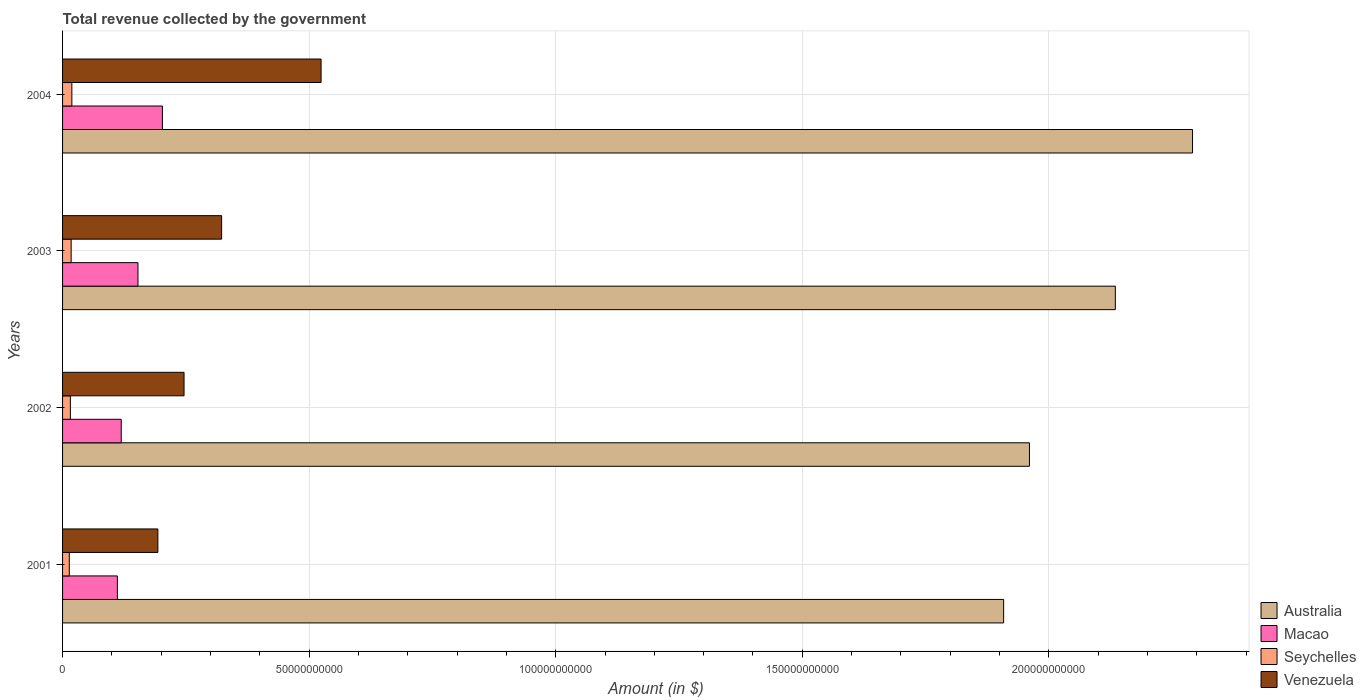Are the number of bars per tick equal to the number of legend labels?
Offer a very short reply. Yes. What is the label of the 4th group of bars from the top?
Ensure brevity in your answer.  2001. In how many cases, is the number of bars for a given year not equal to the number of legend labels?
Give a very brief answer. 0. What is the total revenue collected by the government in Macao in 2003?
Ensure brevity in your answer.  1.53e+1. Across all years, what is the maximum total revenue collected by the government in Macao?
Give a very brief answer. 2.02e+1. Across all years, what is the minimum total revenue collected by the government in Macao?
Provide a succinct answer. 1.11e+1. In which year was the total revenue collected by the government in Venezuela maximum?
Your answer should be compact. 2004. What is the total total revenue collected by the government in Venezuela in the graph?
Offer a very short reply. 1.29e+11. What is the difference between the total revenue collected by the government in Macao in 2001 and that in 2004?
Make the answer very short. -9.14e+09. What is the difference between the total revenue collected by the government in Seychelles in 2004 and the total revenue collected by the government in Venezuela in 2003?
Provide a succinct answer. -3.04e+1. What is the average total revenue collected by the government in Seychelles per year?
Your answer should be compact. 1.64e+09. In the year 2004, what is the difference between the total revenue collected by the government in Australia and total revenue collected by the government in Venezuela?
Provide a short and direct response. 1.77e+11. In how many years, is the total revenue collected by the government in Seychelles greater than 160000000000 $?
Your answer should be very brief. 0. What is the ratio of the total revenue collected by the government in Venezuela in 2001 to that in 2002?
Make the answer very short. 0.78. What is the difference between the highest and the second highest total revenue collected by the government in Macao?
Offer a very short reply. 4.96e+09. What is the difference between the highest and the lowest total revenue collected by the government in Seychelles?
Your response must be concise. 5.19e+08. In how many years, is the total revenue collected by the government in Venezuela greater than the average total revenue collected by the government in Venezuela taken over all years?
Your answer should be compact. 2. Is the sum of the total revenue collected by the government in Macao in 2001 and 2002 greater than the maximum total revenue collected by the government in Australia across all years?
Your answer should be compact. No. What does the 2nd bar from the bottom in 2002 represents?
Your response must be concise. Macao. Is it the case that in every year, the sum of the total revenue collected by the government in Venezuela and total revenue collected by the government in Macao is greater than the total revenue collected by the government in Australia?
Your response must be concise. No. How many years are there in the graph?
Provide a short and direct response. 4. Are the values on the major ticks of X-axis written in scientific E-notation?
Provide a short and direct response. No. Does the graph contain grids?
Your answer should be very brief. Yes. Where does the legend appear in the graph?
Offer a terse response. Bottom right. How many legend labels are there?
Make the answer very short. 4. What is the title of the graph?
Provide a succinct answer. Total revenue collected by the government. Does "Nicaragua" appear as one of the legend labels in the graph?
Your answer should be compact. No. What is the label or title of the X-axis?
Provide a succinct answer. Amount (in $). What is the Amount (in $) in Australia in 2001?
Give a very brief answer. 1.91e+11. What is the Amount (in $) in Macao in 2001?
Make the answer very short. 1.11e+1. What is the Amount (in $) of Seychelles in 2001?
Your response must be concise. 1.36e+09. What is the Amount (in $) of Venezuela in 2001?
Give a very brief answer. 1.93e+1. What is the Amount (in $) of Australia in 2002?
Provide a short and direct response. 1.96e+11. What is the Amount (in $) of Macao in 2002?
Make the answer very short. 1.19e+1. What is the Amount (in $) in Seychelles in 2002?
Your response must be concise. 1.58e+09. What is the Amount (in $) of Venezuela in 2002?
Offer a very short reply. 2.46e+1. What is the Amount (in $) in Australia in 2003?
Offer a terse response. 2.13e+11. What is the Amount (in $) in Macao in 2003?
Give a very brief answer. 1.53e+1. What is the Amount (in $) in Seychelles in 2003?
Offer a terse response. 1.74e+09. What is the Amount (in $) in Venezuela in 2003?
Provide a short and direct response. 3.23e+1. What is the Amount (in $) of Australia in 2004?
Your answer should be compact. 2.29e+11. What is the Amount (in $) in Macao in 2004?
Your answer should be compact. 2.02e+1. What is the Amount (in $) of Seychelles in 2004?
Your response must be concise. 1.88e+09. What is the Amount (in $) of Venezuela in 2004?
Provide a succinct answer. 5.24e+1. Across all years, what is the maximum Amount (in $) in Australia?
Offer a very short reply. 2.29e+11. Across all years, what is the maximum Amount (in $) of Macao?
Your response must be concise. 2.02e+1. Across all years, what is the maximum Amount (in $) in Seychelles?
Offer a terse response. 1.88e+09. Across all years, what is the maximum Amount (in $) in Venezuela?
Give a very brief answer. 5.24e+1. Across all years, what is the minimum Amount (in $) of Australia?
Your answer should be compact. 1.91e+11. Across all years, what is the minimum Amount (in $) of Macao?
Offer a very short reply. 1.11e+1. Across all years, what is the minimum Amount (in $) of Seychelles?
Provide a succinct answer. 1.36e+09. Across all years, what is the minimum Amount (in $) in Venezuela?
Your answer should be compact. 1.93e+1. What is the total Amount (in $) in Australia in the graph?
Ensure brevity in your answer.  8.29e+11. What is the total Amount (in $) of Macao in the graph?
Make the answer very short. 5.85e+1. What is the total Amount (in $) in Seychelles in the graph?
Your answer should be compact. 6.57e+09. What is the total Amount (in $) in Venezuela in the graph?
Ensure brevity in your answer.  1.29e+11. What is the difference between the Amount (in $) of Australia in 2001 and that in 2002?
Make the answer very short. -5.24e+09. What is the difference between the Amount (in $) of Macao in 2001 and that in 2002?
Provide a short and direct response. -7.85e+08. What is the difference between the Amount (in $) in Seychelles in 2001 and that in 2002?
Offer a very short reply. -2.17e+08. What is the difference between the Amount (in $) in Venezuela in 2001 and that in 2002?
Give a very brief answer. -5.31e+09. What is the difference between the Amount (in $) of Australia in 2001 and that in 2003?
Make the answer very short. -2.27e+1. What is the difference between the Amount (in $) of Macao in 2001 and that in 2003?
Provide a short and direct response. -4.18e+09. What is the difference between the Amount (in $) of Seychelles in 2001 and that in 2003?
Your answer should be very brief. -3.78e+08. What is the difference between the Amount (in $) in Venezuela in 2001 and that in 2003?
Give a very brief answer. -1.29e+1. What is the difference between the Amount (in $) of Australia in 2001 and that in 2004?
Provide a succinct answer. -3.83e+1. What is the difference between the Amount (in $) in Macao in 2001 and that in 2004?
Offer a terse response. -9.14e+09. What is the difference between the Amount (in $) of Seychelles in 2001 and that in 2004?
Your response must be concise. -5.19e+08. What is the difference between the Amount (in $) in Venezuela in 2001 and that in 2004?
Provide a short and direct response. -3.31e+1. What is the difference between the Amount (in $) of Australia in 2002 and that in 2003?
Keep it short and to the point. -1.74e+1. What is the difference between the Amount (in $) in Macao in 2002 and that in 2003?
Offer a terse response. -3.39e+09. What is the difference between the Amount (in $) of Seychelles in 2002 and that in 2003?
Offer a terse response. -1.61e+08. What is the difference between the Amount (in $) of Venezuela in 2002 and that in 2003?
Your response must be concise. -7.62e+09. What is the difference between the Amount (in $) of Australia in 2002 and that in 2004?
Keep it short and to the point. -3.31e+1. What is the difference between the Amount (in $) of Macao in 2002 and that in 2004?
Your answer should be very brief. -8.35e+09. What is the difference between the Amount (in $) of Seychelles in 2002 and that in 2004?
Offer a terse response. -3.02e+08. What is the difference between the Amount (in $) in Venezuela in 2002 and that in 2004?
Offer a very short reply. -2.78e+1. What is the difference between the Amount (in $) in Australia in 2003 and that in 2004?
Provide a short and direct response. -1.56e+1. What is the difference between the Amount (in $) in Macao in 2003 and that in 2004?
Keep it short and to the point. -4.96e+09. What is the difference between the Amount (in $) of Seychelles in 2003 and that in 2004?
Provide a succinct answer. -1.41e+08. What is the difference between the Amount (in $) in Venezuela in 2003 and that in 2004?
Your response must be concise. -2.02e+1. What is the difference between the Amount (in $) of Australia in 2001 and the Amount (in $) of Macao in 2002?
Give a very brief answer. 1.79e+11. What is the difference between the Amount (in $) of Australia in 2001 and the Amount (in $) of Seychelles in 2002?
Offer a terse response. 1.89e+11. What is the difference between the Amount (in $) in Australia in 2001 and the Amount (in $) in Venezuela in 2002?
Ensure brevity in your answer.  1.66e+11. What is the difference between the Amount (in $) of Macao in 2001 and the Amount (in $) of Seychelles in 2002?
Provide a short and direct response. 9.53e+09. What is the difference between the Amount (in $) of Macao in 2001 and the Amount (in $) of Venezuela in 2002?
Ensure brevity in your answer.  -1.35e+1. What is the difference between the Amount (in $) of Seychelles in 2001 and the Amount (in $) of Venezuela in 2002?
Provide a succinct answer. -2.33e+1. What is the difference between the Amount (in $) in Australia in 2001 and the Amount (in $) in Macao in 2003?
Offer a very short reply. 1.76e+11. What is the difference between the Amount (in $) of Australia in 2001 and the Amount (in $) of Seychelles in 2003?
Your answer should be compact. 1.89e+11. What is the difference between the Amount (in $) of Australia in 2001 and the Amount (in $) of Venezuela in 2003?
Give a very brief answer. 1.59e+11. What is the difference between the Amount (in $) in Macao in 2001 and the Amount (in $) in Seychelles in 2003?
Make the answer very short. 9.37e+09. What is the difference between the Amount (in $) in Macao in 2001 and the Amount (in $) in Venezuela in 2003?
Make the answer very short. -2.11e+1. What is the difference between the Amount (in $) in Seychelles in 2001 and the Amount (in $) in Venezuela in 2003?
Make the answer very short. -3.09e+1. What is the difference between the Amount (in $) in Australia in 2001 and the Amount (in $) in Macao in 2004?
Ensure brevity in your answer.  1.71e+11. What is the difference between the Amount (in $) in Australia in 2001 and the Amount (in $) in Seychelles in 2004?
Your answer should be very brief. 1.89e+11. What is the difference between the Amount (in $) of Australia in 2001 and the Amount (in $) of Venezuela in 2004?
Your answer should be compact. 1.38e+11. What is the difference between the Amount (in $) in Macao in 2001 and the Amount (in $) in Seychelles in 2004?
Keep it short and to the point. 9.23e+09. What is the difference between the Amount (in $) of Macao in 2001 and the Amount (in $) of Venezuela in 2004?
Provide a short and direct response. -4.13e+1. What is the difference between the Amount (in $) in Seychelles in 2001 and the Amount (in $) in Venezuela in 2004?
Your response must be concise. -5.11e+1. What is the difference between the Amount (in $) of Australia in 2002 and the Amount (in $) of Macao in 2003?
Offer a terse response. 1.81e+11. What is the difference between the Amount (in $) of Australia in 2002 and the Amount (in $) of Seychelles in 2003?
Provide a succinct answer. 1.94e+11. What is the difference between the Amount (in $) in Australia in 2002 and the Amount (in $) in Venezuela in 2003?
Provide a short and direct response. 1.64e+11. What is the difference between the Amount (in $) of Macao in 2002 and the Amount (in $) of Seychelles in 2003?
Make the answer very short. 1.02e+1. What is the difference between the Amount (in $) of Macao in 2002 and the Amount (in $) of Venezuela in 2003?
Your answer should be very brief. -2.04e+1. What is the difference between the Amount (in $) of Seychelles in 2002 and the Amount (in $) of Venezuela in 2003?
Offer a very short reply. -3.07e+1. What is the difference between the Amount (in $) in Australia in 2002 and the Amount (in $) in Macao in 2004?
Keep it short and to the point. 1.76e+11. What is the difference between the Amount (in $) in Australia in 2002 and the Amount (in $) in Seychelles in 2004?
Give a very brief answer. 1.94e+11. What is the difference between the Amount (in $) in Australia in 2002 and the Amount (in $) in Venezuela in 2004?
Keep it short and to the point. 1.44e+11. What is the difference between the Amount (in $) of Macao in 2002 and the Amount (in $) of Seychelles in 2004?
Provide a short and direct response. 1.00e+1. What is the difference between the Amount (in $) in Macao in 2002 and the Amount (in $) in Venezuela in 2004?
Give a very brief answer. -4.05e+1. What is the difference between the Amount (in $) of Seychelles in 2002 and the Amount (in $) of Venezuela in 2004?
Provide a succinct answer. -5.08e+1. What is the difference between the Amount (in $) in Australia in 2003 and the Amount (in $) in Macao in 2004?
Your answer should be very brief. 1.93e+11. What is the difference between the Amount (in $) of Australia in 2003 and the Amount (in $) of Seychelles in 2004?
Provide a short and direct response. 2.12e+11. What is the difference between the Amount (in $) in Australia in 2003 and the Amount (in $) in Venezuela in 2004?
Offer a terse response. 1.61e+11. What is the difference between the Amount (in $) in Macao in 2003 and the Amount (in $) in Seychelles in 2004?
Your answer should be compact. 1.34e+1. What is the difference between the Amount (in $) in Macao in 2003 and the Amount (in $) in Venezuela in 2004?
Offer a terse response. -3.71e+1. What is the difference between the Amount (in $) of Seychelles in 2003 and the Amount (in $) of Venezuela in 2004?
Your response must be concise. -5.07e+1. What is the average Amount (in $) in Australia per year?
Offer a very short reply. 2.07e+11. What is the average Amount (in $) of Macao per year?
Give a very brief answer. 1.46e+1. What is the average Amount (in $) of Seychelles per year?
Keep it short and to the point. 1.64e+09. What is the average Amount (in $) of Venezuela per year?
Offer a terse response. 3.22e+1. In the year 2001, what is the difference between the Amount (in $) of Australia and Amount (in $) of Macao?
Provide a succinct answer. 1.80e+11. In the year 2001, what is the difference between the Amount (in $) of Australia and Amount (in $) of Seychelles?
Make the answer very short. 1.89e+11. In the year 2001, what is the difference between the Amount (in $) of Australia and Amount (in $) of Venezuela?
Make the answer very short. 1.71e+11. In the year 2001, what is the difference between the Amount (in $) of Macao and Amount (in $) of Seychelles?
Offer a very short reply. 9.75e+09. In the year 2001, what is the difference between the Amount (in $) in Macao and Amount (in $) in Venezuela?
Make the answer very short. -8.22e+09. In the year 2001, what is the difference between the Amount (in $) in Seychelles and Amount (in $) in Venezuela?
Offer a terse response. -1.80e+1. In the year 2002, what is the difference between the Amount (in $) of Australia and Amount (in $) of Macao?
Offer a very short reply. 1.84e+11. In the year 2002, what is the difference between the Amount (in $) in Australia and Amount (in $) in Seychelles?
Your response must be concise. 1.94e+11. In the year 2002, what is the difference between the Amount (in $) in Australia and Amount (in $) in Venezuela?
Ensure brevity in your answer.  1.71e+11. In the year 2002, what is the difference between the Amount (in $) in Macao and Amount (in $) in Seychelles?
Keep it short and to the point. 1.03e+1. In the year 2002, what is the difference between the Amount (in $) in Macao and Amount (in $) in Venezuela?
Provide a short and direct response. -1.27e+1. In the year 2002, what is the difference between the Amount (in $) of Seychelles and Amount (in $) of Venezuela?
Your response must be concise. -2.31e+1. In the year 2003, what is the difference between the Amount (in $) of Australia and Amount (in $) of Macao?
Offer a very short reply. 1.98e+11. In the year 2003, what is the difference between the Amount (in $) of Australia and Amount (in $) of Seychelles?
Your answer should be very brief. 2.12e+11. In the year 2003, what is the difference between the Amount (in $) in Australia and Amount (in $) in Venezuela?
Give a very brief answer. 1.81e+11. In the year 2003, what is the difference between the Amount (in $) of Macao and Amount (in $) of Seychelles?
Offer a very short reply. 1.35e+1. In the year 2003, what is the difference between the Amount (in $) of Macao and Amount (in $) of Venezuela?
Your answer should be very brief. -1.70e+1. In the year 2003, what is the difference between the Amount (in $) of Seychelles and Amount (in $) of Venezuela?
Offer a terse response. -3.05e+1. In the year 2004, what is the difference between the Amount (in $) of Australia and Amount (in $) of Macao?
Your answer should be very brief. 2.09e+11. In the year 2004, what is the difference between the Amount (in $) in Australia and Amount (in $) in Seychelles?
Make the answer very short. 2.27e+11. In the year 2004, what is the difference between the Amount (in $) of Australia and Amount (in $) of Venezuela?
Your answer should be compact. 1.77e+11. In the year 2004, what is the difference between the Amount (in $) in Macao and Amount (in $) in Seychelles?
Give a very brief answer. 1.84e+1. In the year 2004, what is the difference between the Amount (in $) in Macao and Amount (in $) in Venezuela?
Provide a short and direct response. -3.22e+1. In the year 2004, what is the difference between the Amount (in $) of Seychelles and Amount (in $) of Venezuela?
Your answer should be very brief. -5.05e+1. What is the ratio of the Amount (in $) of Australia in 2001 to that in 2002?
Keep it short and to the point. 0.97. What is the ratio of the Amount (in $) in Macao in 2001 to that in 2002?
Provide a short and direct response. 0.93. What is the ratio of the Amount (in $) of Seychelles in 2001 to that in 2002?
Your answer should be compact. 0.86. What is the ratio of the Amount (in $) in Venezuela in 2001 to that in 2002?
Provide a short and direct response. 0.78. What is the ratio of the Amount (in $) of Australia in 2001 to that in 2003?
Your answer should be compact. 0.89. What is the ratio of the Amount (in $) in Macao in 2001 to that in 2003?
Your response must be concise. 0.73. What is the ratio of the Amount (in $) of Seychelles in 2001 to that in 2003?
Keep it short and to the point. 0.78. What is the ratio of the Amount (in $) of Venezuela in 2001 to that in 2003?
Offer a terse response. 0.6. What is the ratio of the Amount (in $) of Australia in 2001 to that in 2004?
Your response must be concise. 0.83. What is the ratio of the Amount (in $) in Macao in 2001 to that in 2004?
Your answer should be very brief. 0.55. What is the ratio of the Amount (in $) in Seychelles in 2001 to that in 2004?
Ensure brevity in your answer.  0.72. What is the ratio of the Amount (in $) of Venezuela in 2001 to that in 2004?
Your answer should be compact. 0.37. What is the ratio of the Amount (in $) of Australia in 2002 to that in 2003?
Your answer should be compact. 0.92. What is the ratio of the Amount (in $) of Macao in 2002 to that in 2003?
Your answer should be very brief. 0.78. What is the ratio of the Amount (in $) of Seychelles in 2002 to that in 2003?
Make the answer very short. 0.91. What is the ratio of the Amount (in $) in Venezuela in 2002 to that in 2003?
Offer a very short reply. 0.76. What is the ratio of the Amount (in $) in Australia in 2002 to that in 2004?
Your answer should be very brief. 0.86. What is the ratio of the Amount (in $) of Macao in 2002 to that in 2004?
Ensure brevity in your answer.  0.59. What is the ratio of the Amount (in $) in Seychelles in 2002 to that in 2004?
Your answer should be very brief. 0.84. What is the ratio of the Amount (in $) of Venezuela in 2002 to that in 2004?
Ensure brevity in your answer.  0.47. What is the ratio of the Amount (in $) of Australia in 2003 to that in 2004?
Ensure brevity in your answer.  0.93. What is the ratio of the Amount (in $) in Macao in 2003 to that in 2004?
Make the answer very short. 0.76. What is the ratio of the Amount (in $) in Seychelles in 2003 to that in 2004?
Make the answer very short. 0.93. What is the ratio of the Amount (in $) of Venezuela in 2003 to that in 2004?
Keep it short and to the point. 0.62. What is the difference between the highest and the second highest Amount (in $) of Australia?
Ensure brevity in your answer.  1.56e+1. What is the difference between the highest and the second highest Amount (in $) of Macao?
Provide a succinct answer. 4.96e+09. What is the difference between the highest and the second highest Amount (in $) in Seychelles?
Provide a short and direct response. 1.41e+08. What is the difference between the highest and the second highest Amount (in $) in Venezuela?
Your response must be concise. 2.02e+1. What is the difference between the highest and the lowest Amount (in $) of Australia?
Your answer should be very brief. 3.83e+1. What is the difference between the highest and the lowest Amount (in $) in Macao?
Keep it short and to the point. 9.14e+09. What is the difference between the highest and the lowest Amount (in $) of Seychelles?
Give a very brief answer. 5.19e+08. What is the difference between the highest and the lowest Amount (in $) in Venezuela?
Offer a very short reply. 3.31e+1. 